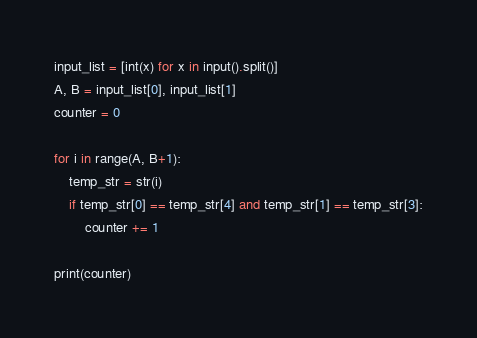<code> <loc_0><loc_0><loc_500><loc_500><_Python_>input_list = [int(x) for x in input().split()]
A, B = input_list[0], input_list[1]
counter = 0

for i in range(A, B+1):
	temp_str = str(i)
	if temp_str[0] == temp_str[4] and temp_str[1] == temp_str[3]:
		counter += 1

print(counter)
</code> 